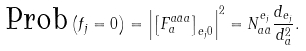Convert formula to latex. <formula><loc_0><loc_0><loc_500><loc_500>\text {Prob} \left ( f _ { j } = 0 \right ) = \left | \left [ F ^ { a \bar { a } a } _ { a } \right ] _ { e _ { j } 0 } \right | ^ { 2 } = N _ { a \bar { a } } ^ { e _ { j } } \frac { d _ { e _ { j } } } { d _ { a } ^ { 2 } } .</formula> 